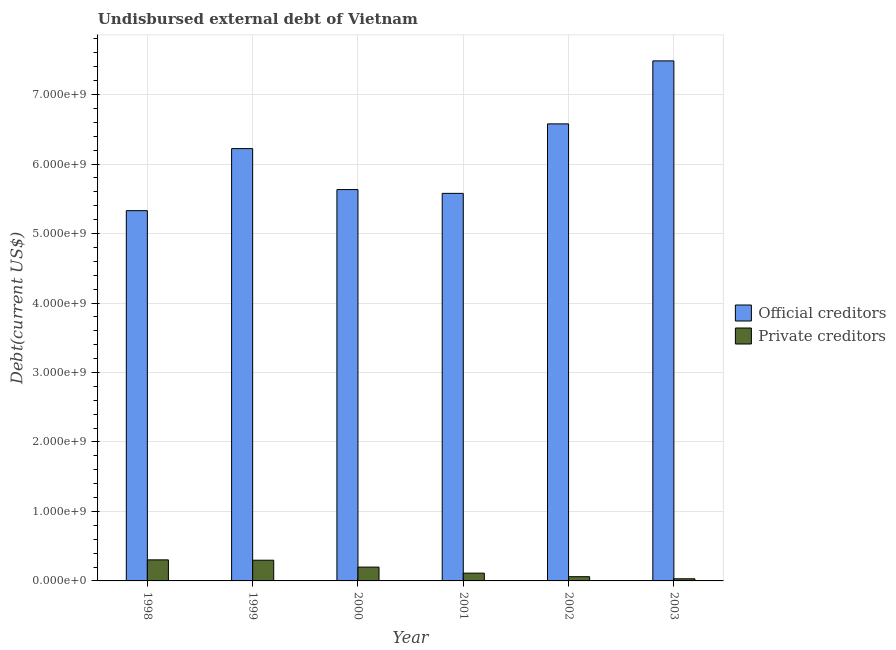How many different coloured bars are there?
Ensure brevity in your answer.  2. How many groups of bars are there?
Offer a very short reply. 6. How many bars are there on the 3rd tick from the left?
Give a very brief answer. 2. How many bars are there on the 3rd tick from the right?
Give a very brief answer. 2. What is the label of the 5th group of bars from the left?
Ensure brevity in your answer.  2002. In how many cases, is the number of bars for a given year not equal to the number of legend labels?
Keep it short and to the point. 0. What is the undisbursed external debt of private creditors in 2003?
Offer a terse response. 3.09e+07. Across all years, what is the maximum undisbursed external debt of private creditors?
Give a very brief answer. 3.03e+08. Across all years, what is the minimum undisbursed external debt of official creditors?
Your response must be concise. 5.33e+09. What is the total undisbursed external debt of private creditors in the graph?
Your response must be concise. 1.00e+09. What is the difference between the undisbursed external debt of private creditors in 1998 and that in 2003?
Provide a succinct answer. 2.72e+08. What is the difference between the undisbursed external debt of official creditors in 1999 and the undisbursed external debt of private creditors in 2003?
Give a very brief answer. -1.26e+09. What is the average undisbursed external debt of official creditors per year?
Provide a succinct answer. 6.14e+09. In the year 1999, what is the difference between the undisbursed external debt of private creditors and undisbursed external debt of official creditors?
Provide a short and direct response. 0. What is the ratio of the undisbursed external debt of private creditors in 1998 to that in 2002?
Your response must be concise. 4.99. Is the undisbursed external debt of private creditors in 2001 less than that in 2002?
Ensure brevity in your answer.  No. What is the difference between the highest and the second highest undisbursed external debt of private creditors?
Your answer should be compact. 5.08e+06. What is the difference between the highest and the lowest undisbursed external debt of official creditors?
Keep it short and to the point. 2.16e+09. Is the sum of the undisbursed external debt of official creditors in 1999 and 2002 greater than the maximum undisbursed external debt of private creditors across all years?
Your answer should be very brief. Yes. What does the 2nd bar from the left in 2002 represents?
Provide a short and direct response. Private creditors. What does the 1st bar from the right in 2002 represents?
Offer a terse response. Private creditors. How many years are there in the graph?
Offer a terse response. 6. Are the values on the major ticks of Y-axis written in scientific E-notation?
Keep it short and to the point. Yes. Does the graph contain any zero values?
Your answer should be very brief. No. Where does the legend appear in the graph?
Give a very brief answer. Center right. How many legend labels are there?
Your answer should be compact. 2. What is the title of the graph?
Keep it short and to the point. Undisbursed external debt of Vietnam. What is the label or title of the Y-axis?
Provide a succinct answer. Debt(current US$). What is the Debt(current US$) in Official creditors in 1998?
Provide a short and direct response. 5.33e+09. What is the Debt(current US$) of Private creditors in 1998?
Make the answer very short. 3.03e+08. What is the Debt(current US$) in Official creditors in 1999?
Your answer should be compact. 6.22e+09. What is the Debt(current US$) of Private creditors in 1999?
Give a very brief answer. 2.98e+08. What is the Debt(current US$) in Official creditors in 2000?
Keep it short and to the point. 5.63e+09. What is the Debt(current US$) in Private creditors in 2000?
Keep it short and to the point. 1.99e+08. What is the Debt(current US$) in Official creditors in 2001?
Offer a very short reply. 5.58e+09. What is the Debt(current US$) in Private creditors in 2001?
Keep it short and to the point. 1.12e+08. What is the Debt(current US$) of Official creditors in 2002?
Your answer should be compact. 6.58e+09. What is the Debt(current US$) of Private creditors in 2002?
Your answer should be compact. 6.08e+07. What is the Debt(current US$) of Official creditors in 2003?
Ensure brevity in your answer.  7.48e+09. What is the Debt(current US$) of Private creditors in 2003?
Your answer should be compact. 3.09e+07. Across all years, what is the maximum Debt(current US$) of Official creditors?
Make the answer very short. 7.48e+09. Across all years, what is the maximum Debt(current US$) of Private creditors?
Ensure brevity in your answer.  3.03e+08. Across all years, what is the minimum Debt(current US$) in Official creditors?
Offer a very short reply. 5.33e+09. Across all years, what is the minimum Debt(current US$) of Private creditors?
Provide a succinct answer. 3.09e+07. What is the total Debt(current US$) of Official creditors in the graph?
Offer a terse response. 3.68e+1. What is the total Debt(current US$) in Private creditors in the graph?
Your response must be concise. 1.00e+09. What is the difference between the Debt(current US$) of Official creditors in 1998 and that in 1999?
Offer a very short reply. -8.93e+08. What is the difference between the Debt(current US$) of Private creditors in 1998 and that in 1999?
Make the answer very short. 5.08e+06. What is the difference between the Debt(current US$) of Official creditors in 1998 and that in 2000?
Keep it short and to the point. -3.03e+08. What is the difference between the Debt(current US$) of Private creditors in 1998 and that in 2000?
Your response must be concise. 1.04e+08. What is the difference between the Debt(current US$) of Official creditors in 1998 and that in 2001?
Provide a short and direct response. -2.49e+08. What is the difference between the Debt(current US$) of Private creditors in 1998 and that in 2001?
Your answer should be compact. 1.91e+08. What is the difference between the Debt(current US$) in Official creditors in 1998 and that in 2002?
Offer a very short reply. -1.25e+09. What is the difference between the Debt(current US$) in Private creditors in 1998 and that in 2002?
Ensure brevity in your answer.  2.42e+08. What is the difference between the Debt(current US$) in Official creditors in 1998 and that in 2003?
Offer a very short reply. -2.16e+09. What is the difference between the Debt(current US$) of Private creditors in 1998 and that in 2003?
Make the answer very short. 2.72e+08. What is the difference between the Debt(current US$) of Official creditors in 1999 and that in 2000?
Your answer should be very brief. 5.90e+08. What is the difference between the Debt(current US$) of Private creditors in 1999 and that in 2000?
Offer a terse response. 9.90e+07. What is the difference between the Debt(current US$) in Official creditors in 1999 and that in 2001?
Make the answer very short. 6.44e+08. What is the difference between the Debt(current US$) in Private creditors in 1999 and that in 2001?
Your answer should be compact. 1.86e+08. What is the difference between the Debt(current US$) in Official creditors in 1999 and that in 2002?
Keep it short and to the point. -3.56e+08. What is the difference between the Debt(current US$) of Private creditors in 1999 and that in 2002?
Ensure brevity in your answer.  2.37e+08. What is the difference between the Debt(current US$) of Official creditors in 1999 and that in 2003?
Keep it short and to the point. -1.26e+09. What is the difference between the Debt(current US$) in Private creditors in 1999 and that in 2003?
Provide a succinct answer. 2.67e+08. What is the difference between the Debt(current US$) of Official creditors in 2000 and that in 2001?
Keep it short and to the point. 5.46e+07. What is the difference between the Debt(current US$) of Private creditors in 2000 and that in 2001?
Provide a succinct answer. 8.71e+07. What is the difference between the Debt(current US$) in Official creditors in 2000 and that in 2002?
Your answer should be compact. -9.46e+08. What is the difference between the Debt(current US$) of Private creditors in 2000 and that in 2002?
Your answer should be very brief. 1.38e+08. What is the difference between the Debt(current US$) in Official creditors in 2000 and that in 2003?
Give a very brief answer. -1.85e+09. What is the difference between the Debt(current US$) in Private creditors in 2000 and that in 2003?
Your answer should be compact. 1.68e+08. What is the difference between the Debt(current US$) in Official creditors in 2001 and that in 2002?
Your response must be concise. -1.00e+09. What is the difference between the Debt(current US$) of Private creditors in 2001 and that in 2002?
Your answer should be very brief. 5.11e+07. What is the difference between the Debt(current US$) of Official creditors in 2001 and that in 2003?
Your response must be concise. -1.91e+09. What is the difference between the Debt(current US$) in Private creditors in 2001 and that in 2003?
Ensure brevity in your answer.  8.10e+07. What is the difference between the Debt(current US$) of Official creditors in 2002 and that in 2003?
Make the answer very short. -9.07e+08. What is the difference between the Debt(current US$) of Private creditors in 2002 and that in 2003?
Keep it short and to the point. 2.99e+07. What is the difference between the Debt(current US$) of Official creditors in 1998 and the Debt(current US$) of Private creditors in 1999?
Provide a succinct answer. 5.03e+09. What is the difference between the Debt(current US$) in Official creditors in 1998 and the Debt(current US$) in Private creditors in 2000?
Your response must be concise. 5.13e+09. What is the difference between the Debt(current US$) of Official creditors in 1998 and the Debt(current US$) of Private creditors in 2001?
Your answer should be very brief. 5.22e+09. What is the difference between the Debt(current US$) of Official creditors in 1998 and the Debt(current US$) of Private creditors in 2002?
Your answer should be very brief. 5.27e+09. What is the difference between the Debt(current US$) in Official creditors in 1998 and the Debt(current US$) in Private creditors in 2003?
Ensure brevity in your answer.  5.30e+09. What is the difference between the Debt(current US$) of Official creditors in 1999 and the Debt(current US$) of Private creditors in 2000?
Your response must be concise. 6.02e+09. What is the difference between the Debt(current US$) in Official creditors in 1999 and the Debt(current US$) in Private creditors in 2001?
Make the answer very short. 6.11e+09. What is the difference between the Debt(current US$) in Official creditors in 1999 and the Debt(current US$) in Private creditors in 2002?
Ensure brevity in your answer.  6.16e+09. What is the difference between the Debt(current US$) in Official creditors in 1999 and the Debt(current US$) in Private creditors in 2003?
Ensure brevity in your answer.  6.19e+09. What is the difference between the Debt(current US$) in Official creditors in 2000 and the Debt(current US$) in Private creditors in 2001?
Offer a terse response. 5.52e+09. What is the difference between the Debt(current US$) in Official creditors in 2000 and the Debt(current US$) in Private creditors in 2002?
Your response must be concise. 5.57e+09. What is the difference between the Debt(current US$) of Official creditors in 2000 and the Debt(current US$) of Private creditors in 2003?
Provide a short and direct response. 5.60e+09. What is the difference between the Debt(current US$) in Official creditors in 2001 and the Debt(current US$) in Private creditors in 2002?
Ensure brevity in your answer.  5.52e+09. What is the difference between the Debt(current US$) in Official creditors in 2001 and the Debt(current US$) in Private creditors in 2003?
Offer a very short reply. 5.55e+09. What is the difference between the Debt(current US$) in Official creditors in 2002 and the Debt(current US$) in Private creditors in 2003?
Provide a succinct answer. 6.55e+09. What is the average Debt(current US$) in Official creditors per year?
Ensure brevity in your answer.  6.14e+09. What is the average Debt(current US$) in Private creditors per year?
Offer a terse response. 1.67e+08. In the year 1998, what is the difference between the Debt(current US$) of Official creditors and Debt(current US$) of Private creditors?
Ensure brevity in your answer.  5.03e+09. In the year 1999, what is the difference between the Debt(current US$) of Official creditors and Debt(current US$) of Private creditors?
Make the answer very short. 5.92e+09. In the year 2000, what is the difference between the Debt(current US$) of Official creditors and Debt(current US$) of Private creditors?
Ensure brevity in your answer.  5.43e+09. In the year 2001, what is the difference between the Debt(current US$) in Official creditors and Debt(current US$) in Private creditors?
Keep it short and to the point. 5.47e+09. In the year 2002, what is the difference between the Debt(current US$) in Official creditors and Debt(current US$) in Private creditors?
Your response must be concise. 6.52e+09. In the year 2003, what is the difference between the Debt(current US$) in Official creditors and Debt(current US$) in Private creditors?
Your answer should be very brief. 7.45e+09. What is the ratio of the Debt(current US$) in Official creditors in 1998 to that in 1999?
Offer a terse response. 0.86. What is the ratio of the Debt(current US$) in Private creditors in 1998 to that in 1999?
Offer a very short reply. 1.02. What is the ratio of the Debt(current US$) in Official creditors in 1998 to that in 2000?
Give a very brief answer. 0.95. What is the ratio of the Debt(current US$) in Private creditors in 1998 to that in 2000?
Keep it short and to the point. 1.52. What is the ratio of the Debt(current US$) of Official creditors in 1998 to that in 2001?
Provide a succinct answer. 0.96. What is the ratio of the Debt(current US$) of Private creditors in 1998 to that in 2001?
Provide a short and direct response. 2.71. What is the ratio of the Debt(current US$) of Official creditors in 1998 to that in 2002?
Provide a short and direct response. 0.81. What is the ratio of the Debt(current US$) of Private creditors in 1998 to that in 2002?
Make the answer very short. 4.99. What is the ratio of the Debt(current US$) of Official creditors in 1998 to that in 2003?
Your answer should be very brief. 0.71. What is the ratio of the Debt(current US$) of Private creditors in 1998 to that in 2003?
Provide a short and direct response. 9.81. What is the ratio of the Debt(current US$) in Official creditors in 1999 to that in 2000?
Your answer should be very brief. 1.1. What is the ratio of the Debt(current US$) of Private creditors in 1999 to that in 2000?
Your response must be concise. 1.5. What is the ratio of the Debt(current US$) of Official creditors in 1999 to that in 2001?
Your response must be concise. 1.12. What is the ratio of the Debt(current US$) in Private creditors in 1999 to that in 2001?
Ensure brevity in your answer.  2.66. What is the ratio of the Debt(current US$) in Official creditors in 1999 to that in 2002?
Your answer should be very brief. 0.95. What is the ratio of the Debt(current US$) in Private creditors in 1999 to that in 2002?
Ensure brevity in your answer.  4.9. What is the ratio of the Debt(current US$) in Official creditors in 1999 to that in 2003?
Provide a succinct answer. 0.83. What is the ratio of the Debt(current US$) in Private creditors in 1999 to that in 2003?
Ensure brevity in your answer.  9.65. What is the ratio of the Debt(current US$) of Official creditors in 2000 to that in 2001?
Offer a terse response. 1.01. What is the ratio of the Debt(current US$) of Private creditors in 2000 to that in 2001?
Keep it short and to the point. 1.78. What is the ratio of the Debt(current US$) in Official creditors in 2000 to that in 2002?
Offer a very short reply. 0.86. What is the ratio of the Debt(current US$) in Private creditors in 2000 to that in 2002?
Keep it short and to the point. 3.27. What is the ratio of the Debt(current US$) of Official creditors in 2000 to that in 2003?
Provide a short and direct response. 0.75. What is the ratio of the Debt(current US$) of Private creditors in 2000 to that in 2003?
Provide a succinct answer. 6.44. What is the ratio of the Debt(current US$) of Official creditors in 2001 to that in 2002?
Your answer should be very brief. 0.85. What is the ratio of the Debt(current US$) of Private creditors in 2001 to that in 2002?
Your response must be concise. 1.84. What is the ratio of the Debt(current US$) in Official creditors in 2001 to that in 2003?
Your response must be concise. 0.75. What is the ratio of the Debt(current US$) of Private creditors in 2001 to that in 2003?
Keep it short and to the point. 3.62. What is the ratio of the Debt(current US$) of Official creditors in 2002 to that in 2003?
Keep it short and to the point. 0.88. What is the ratio of the Debt(current US$) of Private creditors in 2002 to that in 2003?
Your answer should be compact. 1.97. What is the difference between the highest and the second highest Debt(current US$) of Official creditors?
Your answer should be very brief. 9.07e+08. What is the difference between the highest and the second highest Debt(current US$) of Private creditors?
Ensure brevity in your answer.  5.08e+06. What is the difference between the highest and the lowest Debt(current US$) in Official creditors?
Keep it short and to the point. 2.16e+09. What is the difference between the highest and the lowest Debt(current US$) of Private creditors?
Offer a very short reply. 2.72e+08. 